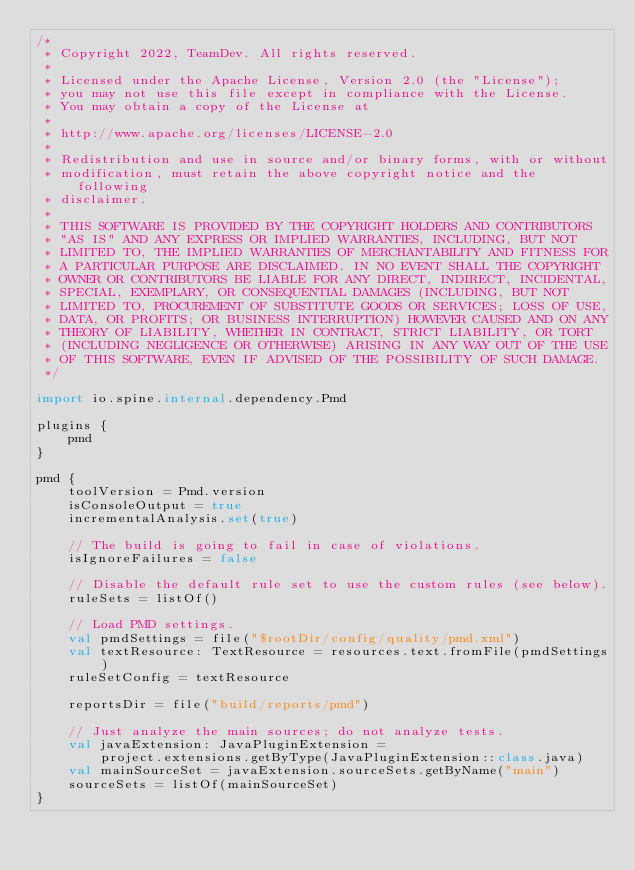<code> <loc_0><loc_0><loc_500><loc_500><_Kotlin_>/*
 * Copyright 2022, TeamDev. All rights reserved.
 *
 * Licensed under the Apache License, Version 2.0 (the "License");
 * you may not use this file except in compliance with the License.
 * You may obtain a copy of the License at
 *
 * http://www.apache.org/licenses/LICENSE-2.0
 *
 * Redistribution and use in source and/or binary forms, with or without
 * modification, must retain the above copyright notice and the following
 * disclaimer.
 *
 * THIS SOFTWARE IS PROVIDED BY THE COPYRIGHT HOLDERS AND CONTRIBUTORS
 * "AS IS" AND ANY EXPRESS OR IMPLIED WARRANTIES, INCLUDING, BUT NOT
 * LIMITED TO, THE IMPLIED WARRANTIES OF MERCHANTABILITY AND FITNESS FOR
 * A PARTICULAR PURPOSE ARE DISCLAIMED. IN NO EVENT SHALL THE COPYRIGHT
 * OWNER OR CONTRIBUTORS BE LIABLE FOR ANY DIRECT, INDIRECT, INCIDENTAL,
 * SPECIAL, EXEMPLARY, OR CONSEQUENTIAL DAMAGES (INCLUDING, BUT NOT
 * LIMITED TO, PROCUREMENT OF SUBSTITUTE GOODS OR SERVICES; LOSS OF USE,
 * DATA, OR PROFITS; OR BUSINESS INTERRUPTION) HOWEVER CAUSED AND ON ANY
 * THEORY OF LIABILITY, WHETHER IN CONTRACT, STRICT LIABILITY, OR TORT
 * (INCLUDING NEGLIGENCE OR OTHERWISE) ARISING IN ANY WAY OUT OF THE USE
 * OF THIS SOFTWARE, EVEN IF ADVISED OF THE POSSIBILITY OF SUCH DAMAGE.
 */

import io.spine.internal.dependency.Pmd

plugins {
    pmd
}

pmd {
    toolVersion = Pmd.version
    isConsoleOutput = true
    incrementalAnalysis.set(true)

    // The build is going to fail in case of violations.
    isIgnoreFailures = false

    // Disable the default rule set to use the custom rules (see below).
    ruleSets = listOf()

    // Load PMD settings.
    val pmdSettings = file("$rootDir/config/quality/pmd.xml")
    val textResource: TextResource = resources.text.fromFile(pmdSettings)
    ruleSetConfig = textResource

    reportsDir = file("build/reports/pmd")

    // Just analyze the main sources; do not analyze tests.
    val javaExtension: JavaPluginExtension =
        project.extensions.getByType(JavaPluginExtension::class.java)
    val mainSourceSet = javaExtension.sourceSets.getByName("main")
    sourceSets = listOf(mainSourceSet)
}
</code> 